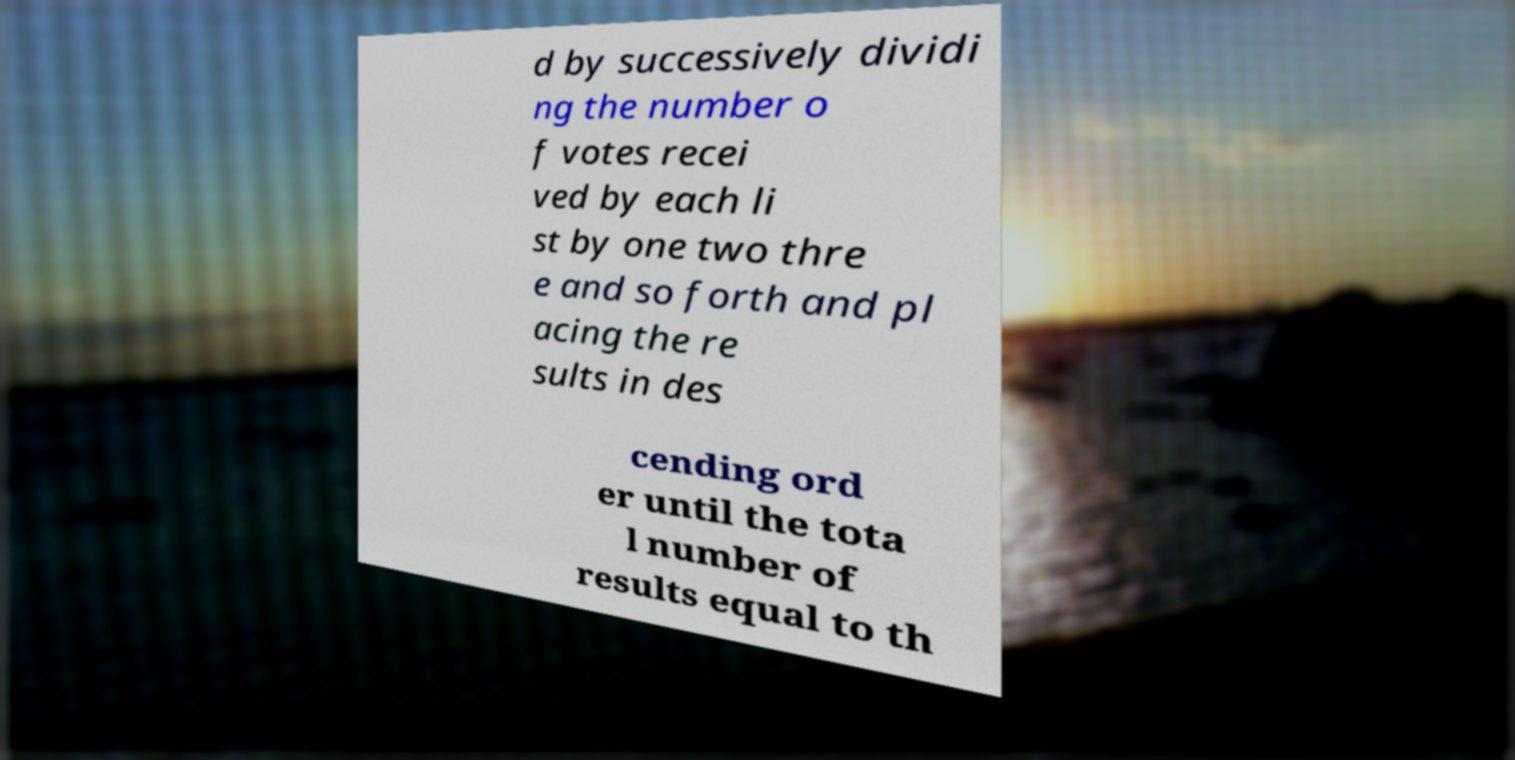For documentation purposes, I need the text within this image transcribed. Could you provide that? d by successively dividi ng the number o f votes recei ved by each li st by one two thre e and so forth and pl acing the re sults in des cending ord er until the tota l number of results equal to th 